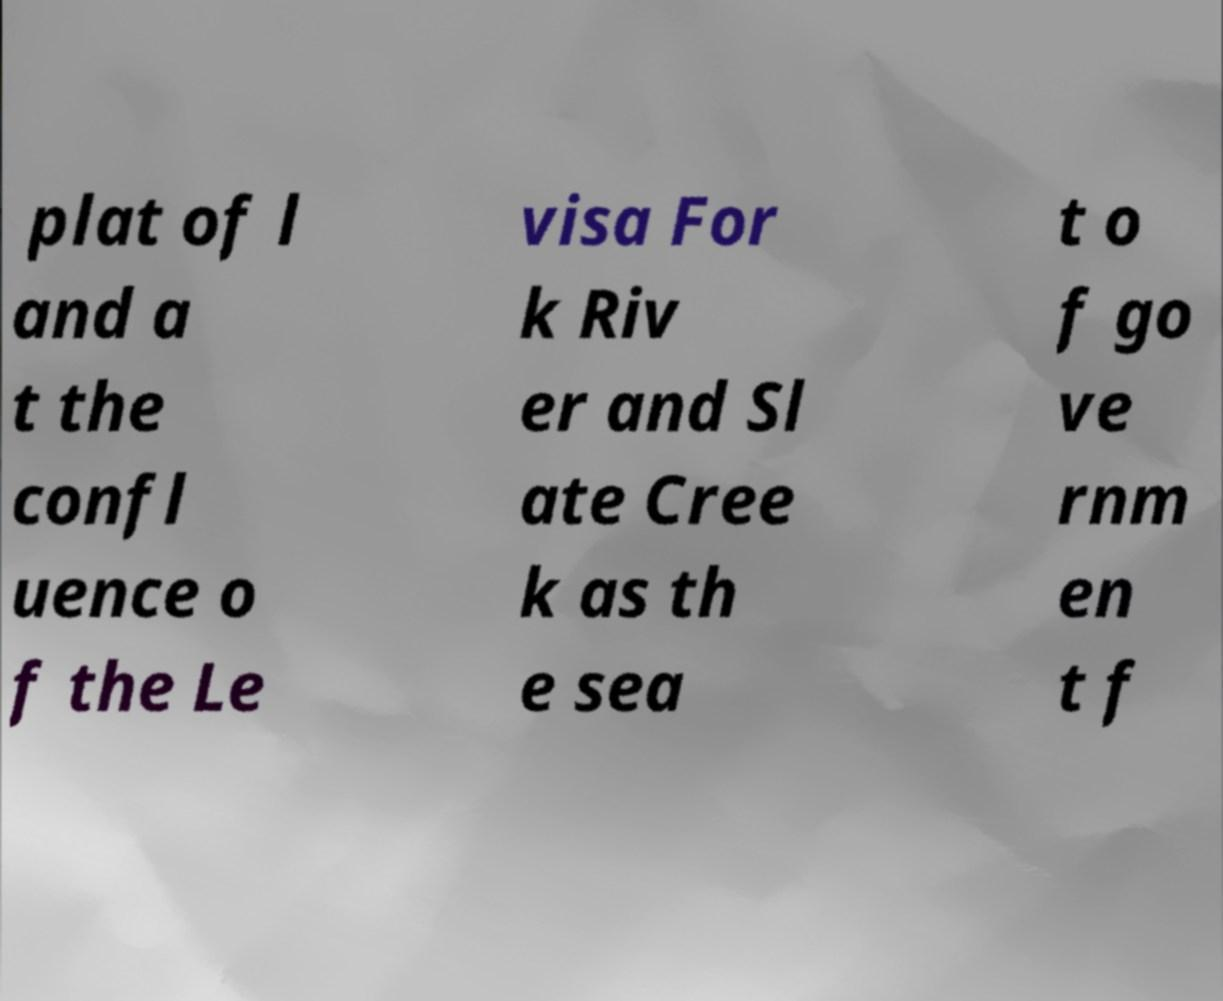Please identify and transcribe the text found in this image. plat of l and a t the confl uence o f the Le visa For k Riv er and Sl ate Cree k as th e sea t o f go ve rnm en t f 